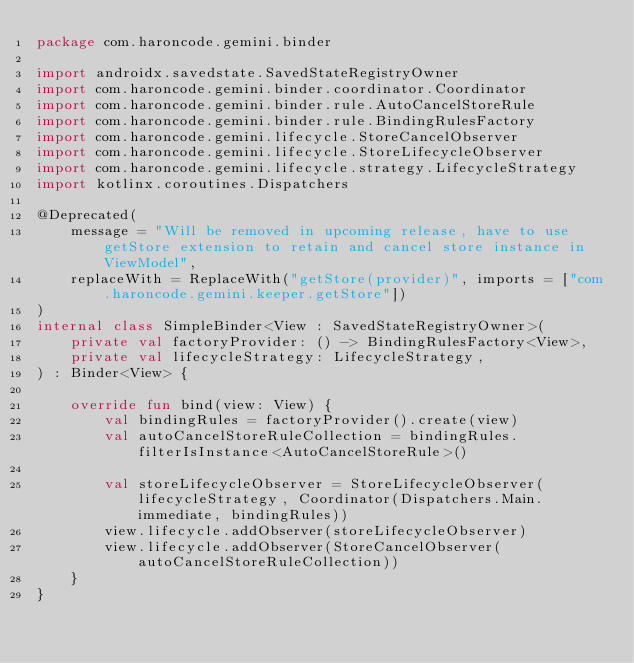<code> <loc_0><loc_0><loc_500><loc_500><_Kotlin_>package com.haroncode.gemini.binder

import androidx.savedstate.SavedStateRegistryOwner
import com.haroncode.gemini.binder.coordinator.Coordinator
import com.haroncode.gemini.binder.rule.AutoCancelStoreRule
import com.haroncode.gemini.binder.rule.BindingRulesFactory
import com.haroncode.gemini.lifecycle.StoreCancelObserver
import com.haroncode.gemini.lifecycle.StoreLifecycleObserver
import com.haroncode.gemini.lifecycle.strategy.LifecycleStrategy
import kotlinx.coroutines.Dispatchers

@Deprecated(
    message = "Will be removed in upcoming release, have to use getStore extension to retain and cancel store instance in ViewModel",
    replaceWith = ReplaceWith("getStore(provider)", imports = ["com.haroncode.gemini.keeper.getStore"])
)
internal class SimpleBinder<View : SavedStateRegistryOwner>(
    private val factoryProvider: () -> BindingRulesFactory<View>,
    private val lifecycleStrategy: LifecycleStrategy,
) : Binder<View> {

    override fun bind(view: View) {
        val bindingRules = factoryProvider().create(view)
        val autoCancelStoreRuleCollection = bindingRules.filterIsInstance<AutoCancelStoreRule>()

        val storeLifecycleObserver = StoreLifecycleObserver(lifecycleStrategy, Coordinator(Dispatchers.Main.immediate, bindingRules))
        view.lifecycle.addObserver(storeLifecycleObserver)
        view.lifecycle.addObserver(StoreCancelObserver(autoCancelStoreRuleCollection))
    }
}
</code> 